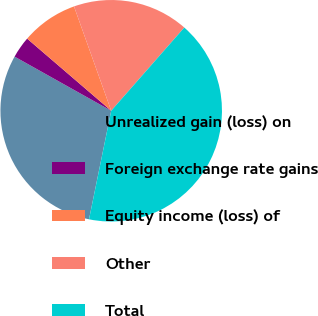Convert chart to OTSL. <chart><loc_0><loc_0><loc_500><loc_500><pie_chart><fcel>Unrealized gain (loss) on<fcel>Foreign exchange rate gains<fcel>Equity income (loss) of<fcel>Other<fcel>Total<nl><fcel>29.92%<fcel>3.16%<fcel>8.26%<fcel>16.92%<fcel>41.74%<nl></chart> 